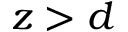Convert formula to latex. <formula><loc_0><loc_0><loc_500><loc_500>z > d</formula> 